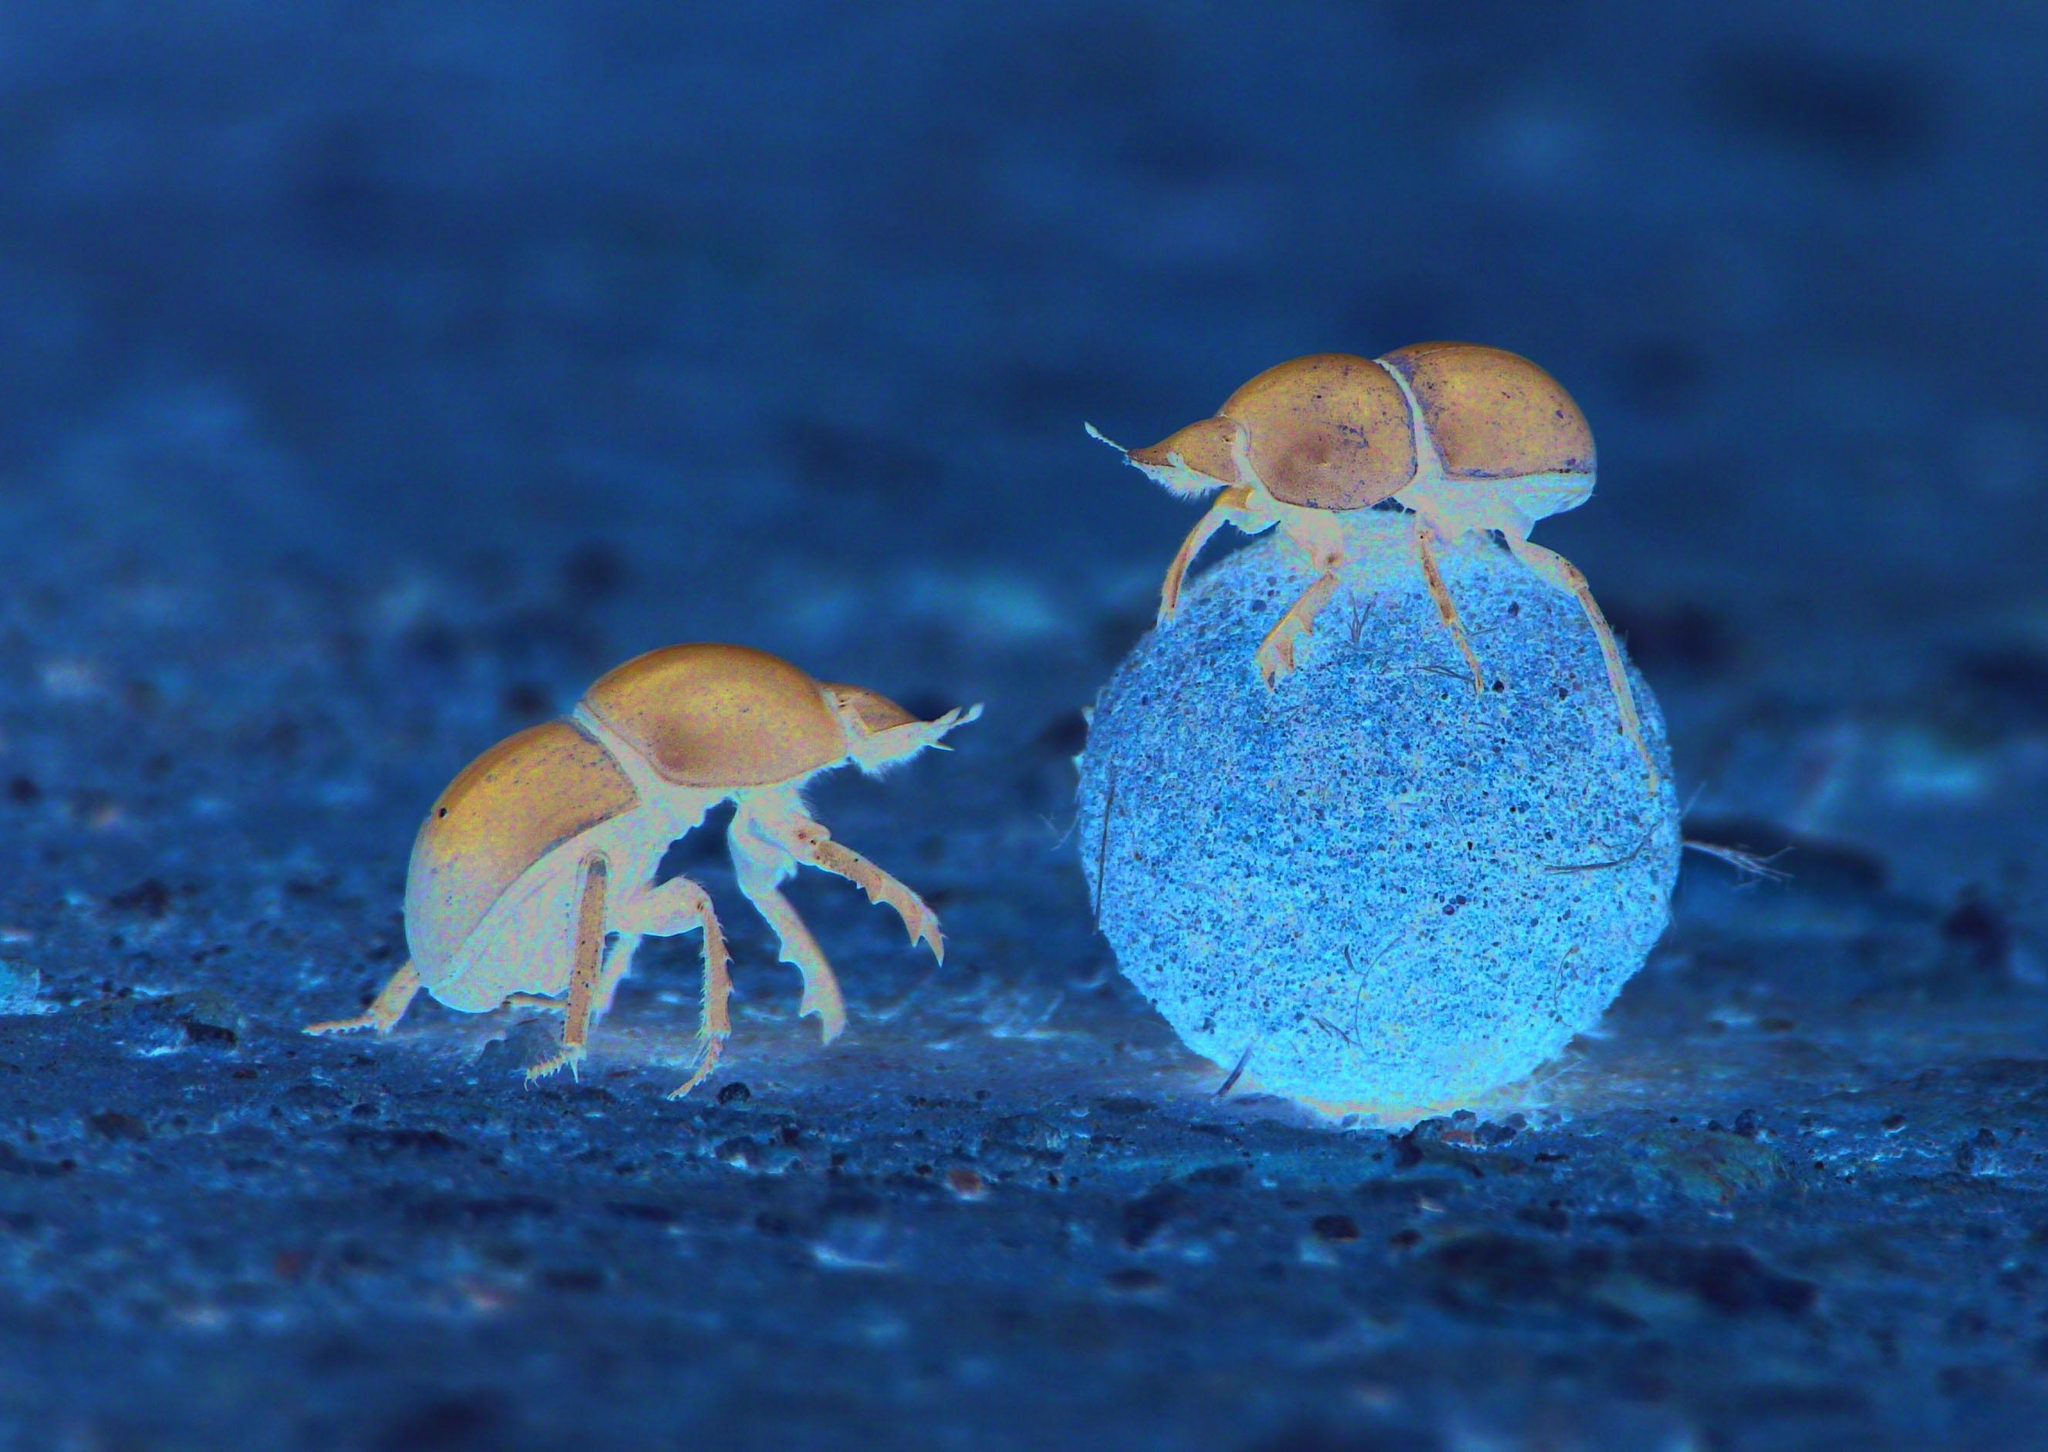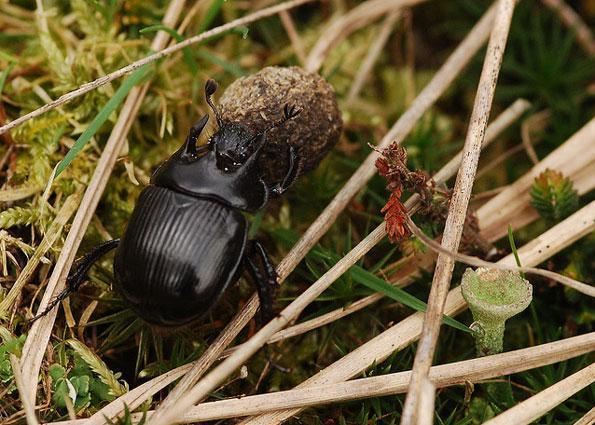The first image is the image on the left, the second image is the image on the right. Analyze the images presented: Is the assertion "There is a single black beetle in the image on the right." valid? Answer yes or no. Yes. 